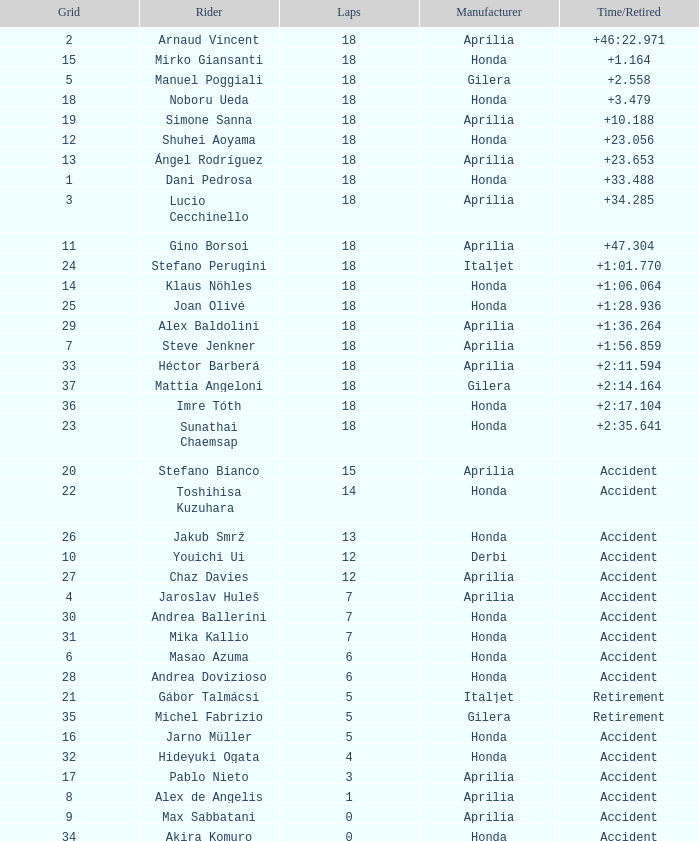Who is the rider with less than 15 laps, more than 32 grids, and an accident time/retired? Akira Komuro. 